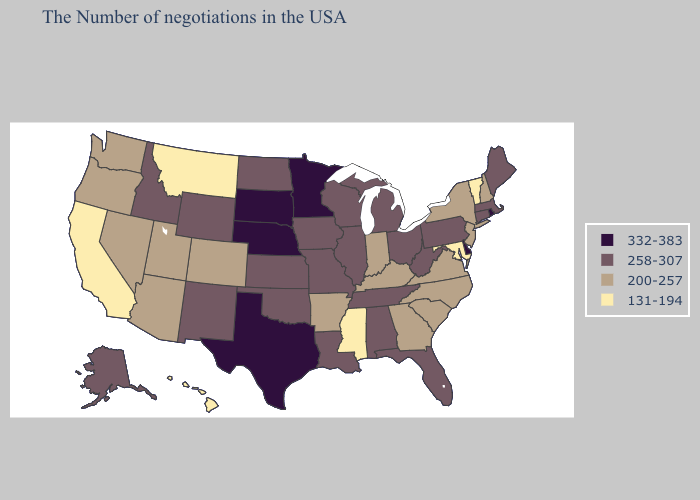Name the states that have a value in the range 200-257?
Give a very brief answer. New Hampshire, New York, New Jersey, Virginia, North Carolina, South Carolina, Georgia, Kentucky, Indiana, Arkansas, Colorado, Utah, Arizona, Nevada, Washington, Oregon. Does Iowa have the lowest value in the MidWest?
Keep it brief. No. Name the states that have a value in the range 332-383?
Write a very short answer. Rhode Island, Delaware, Minnesota, Nebraska, Texas, South Dakota. Among the states that border Utah , which have the highest value?
Write a very short answer. Wyoming, New Mexico, Idaho. How many symbols are there in the legend?
Answer briefly. 4. Name the states that have a value in the range 258-307?
Keep it brief. Maine, Massachusetts, Connecticut, Pennsylvania, West Virginia, Ohio, Florida, Michigan, Alabama, Tennessee, Wisconsin, Illinois, Louisiana, Missouri, Iowa, Kansas, Oklahoma, North Dakota, Wyoming, New Mexico, Idaho, Alaska. Which states hav the highest value in the West?
Write a very short answer. Wyoming, New Mexico, Idaho, Alaska. What is the lowest value in the South?
Short answer required. 131-194. Which states have the lowest value in the USA?
Keep it brief. Vermont, Maryland, Mississippi, Montana, California, Hawaii. Among the states that border Indiana , does Illinois have the lowest value?
Give a very brief answer. No. Name the states that have a value in the range 258-307?
Concise answer only. Maine, Massachusetts, Connecticut, Pennsylvania, West Virginia, Ohio, Florida, Michigan, Alabama, Tennessee, Wisconsin, Illinois, Louisiana, Missouri, Iowa, Kansas, Oklahoma, North Dakota, Wyoming, New Mexico, Idaho, Alaska. What is the value of Wisconsin?
Quick response, please. 258-307. What is the value of South Carolina?
Be succinct. 200-257. Does California have the lowest value in the USA?
Write a very short answer. Yes. What is the lowest value in the USA?
Write a very short answer. 131-194. 